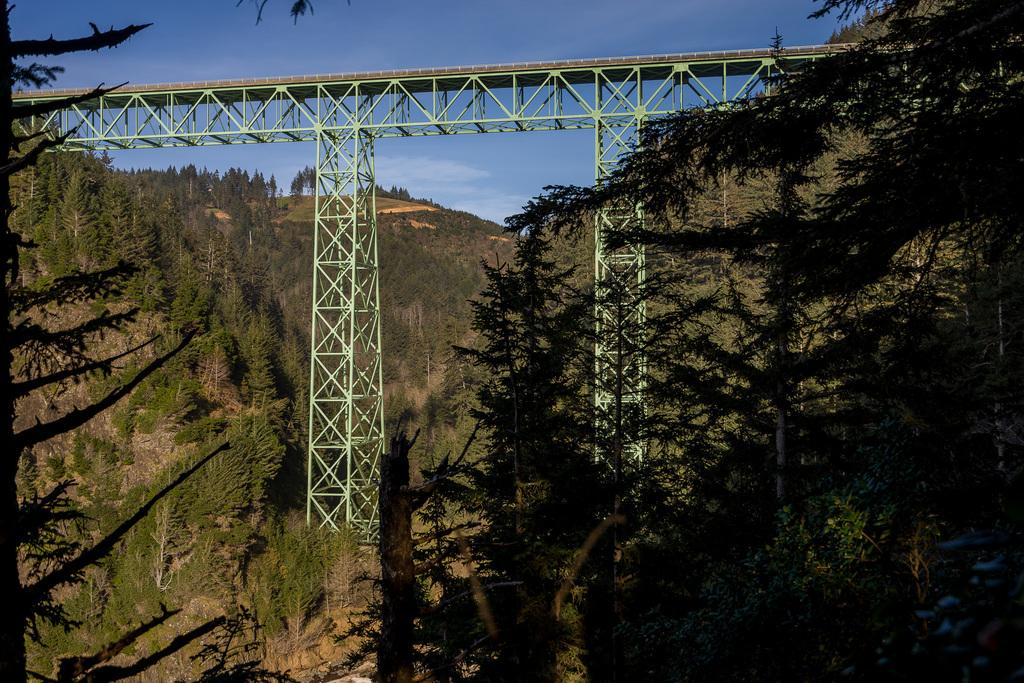What type of landscape is depicted in the image? There are hills with trees in the image. What man-made structure can be seen in the image? There is a bridge in the image. Can you describe the bridge's design? The bridge has towers and fencing made of rods. What type of dirt can be seen on the bridge in the image? There is no dirt visible on the bridge in the image. Can you describe the truck that is parked on the bridge? There is no truck present in the image. 